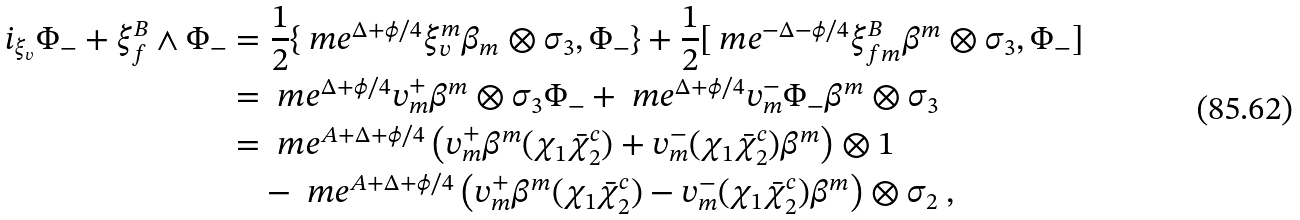Convert formula to latex. <formula><loc_0><loc_0><loc_500><loc_500>i _ { \xi _ { v } } \Phi _ { - } + \xi ^ { B } _ { f } \wedge \Phi _ { - } & = \frac { 1 } { 2 } \{ \ m e ^ { \Delta + \phi / 4 } \xi _ { v } ^ { m } \beta _ { m } \otimes \sigma _ { 3 } , \Phi _ { - } \} + \frac { 1 } { 2 } [ \ m e ^ { - \Delta - \phi / 4 } \xi _ { f m } ^ { B } \beta ^ { m } \otimes \sigma _ { 3 } , \Phi _ { - } ] \\ & = \ m e ^ { \Delta + \phi / 4 } v ^ { + } _ { m } \beta ^ { m } \otimes \sigma _ { 3 } \Phi _ { - } + \ m e ^ { \Delta + \phi / 4 } v ^ { - } _ { m } \Phi _ { - } \beta ^ { m } \otimes \sigma _ { 3 } \\ & = \ m e ^ { A + \Delta + \phi / 4 } \left ( v ^ { + } _ { m } \beta ^ { m } ( \chi _ { 1 } \bar { \chi } _ { 2 } ^ { c } ) + v ^ { - } _ { m } ( \chi _ { 1 } \bar { \chi } _ { 2 } ^ { c } ) \beta ^ { m } \right ) \otimes 1 \\ & \quad - \ m e ^ { A + \Delta + \phi / 4 } \left ( v ^ { + } _ { m } \beta ^ { m } ( \chi _ { 1 } \bar { \chi } _ { 2 } ^ { c } ) - v ^ { - } _ { m } ( \chi _ { 1 } \bar { \chi } _ { 2 } ^ { c } ) \beta ^ { m } \right ) \otimes \sigma _ { 2 } \ ,</formula> 